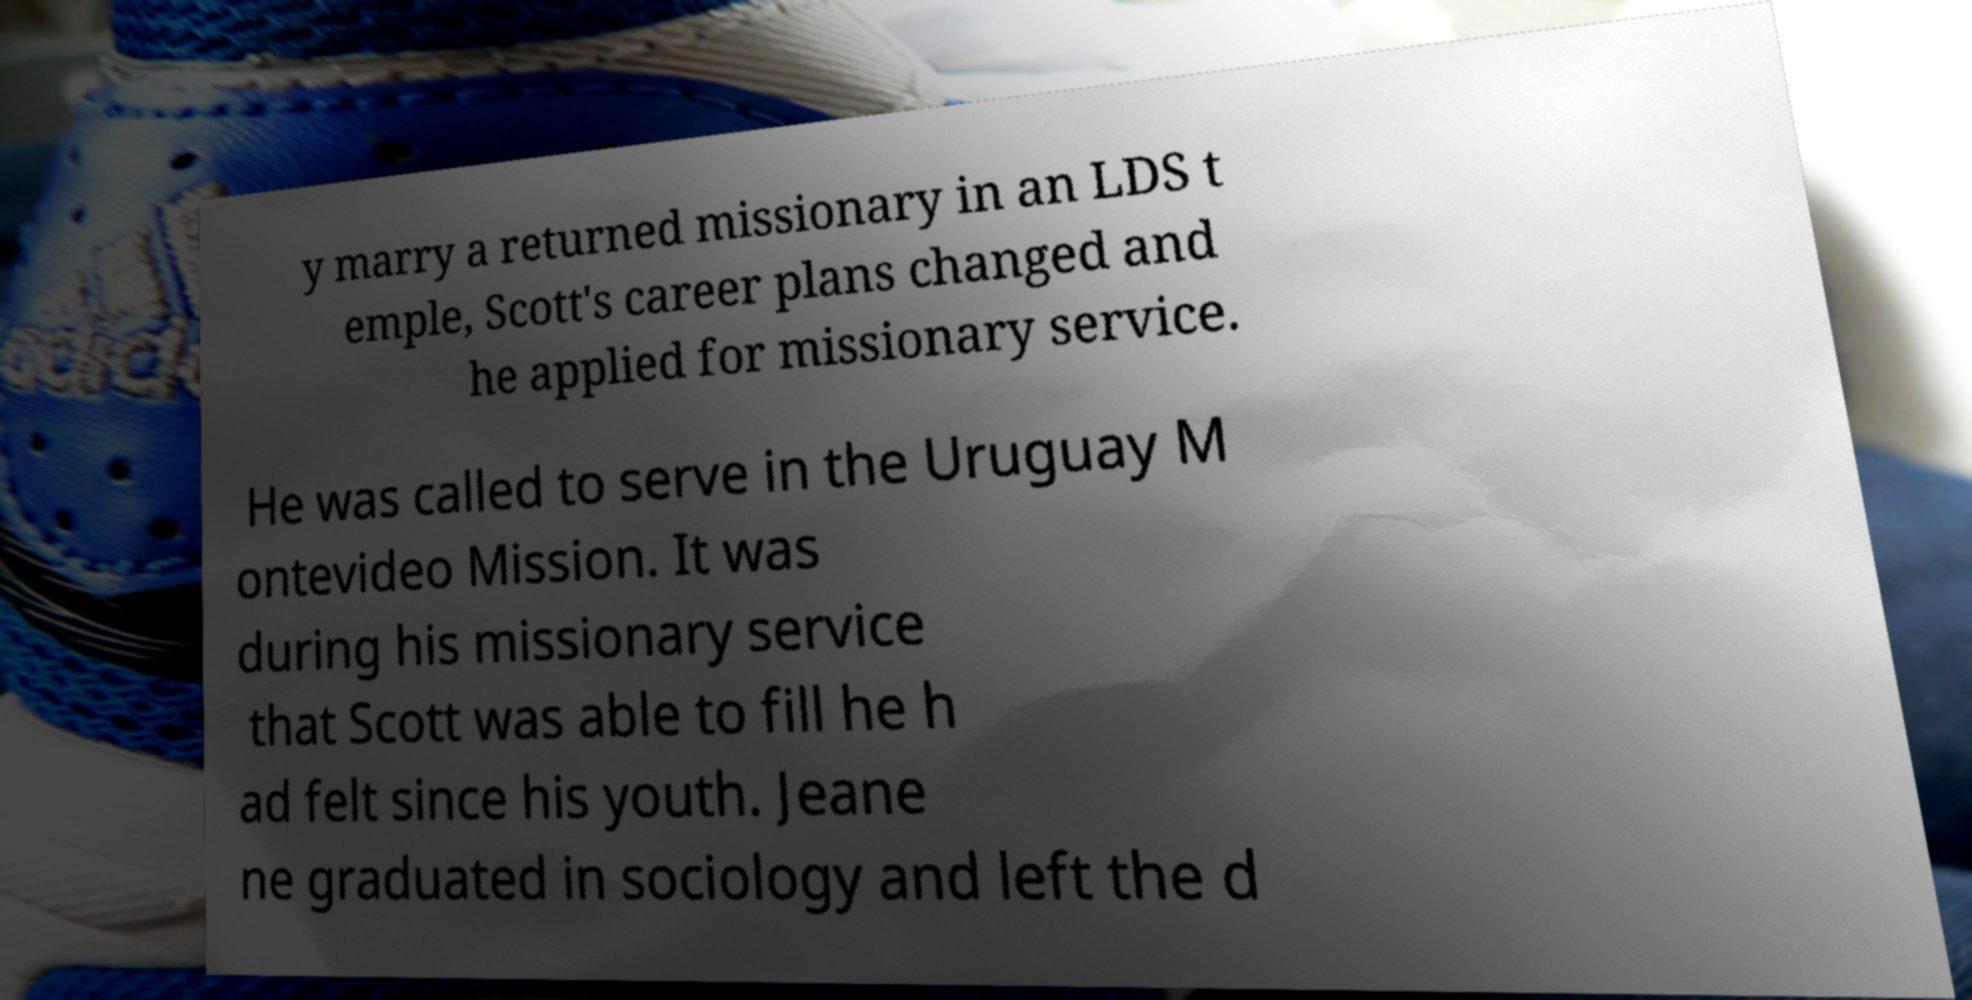Can you read and provide the text displayed in the image?This photo seems to have some interesting text. Can you extract and type it out for me? y marry a returned missionary in an LDS t emple, Scott's career plans changed and he applied for missionary service. He was called to serve in the Uruguay M ontevideo Mission. It was during his missionary service that Scott was able to fill he h ad felt since his youth. Jeane ne graduated in sociology and left the d 